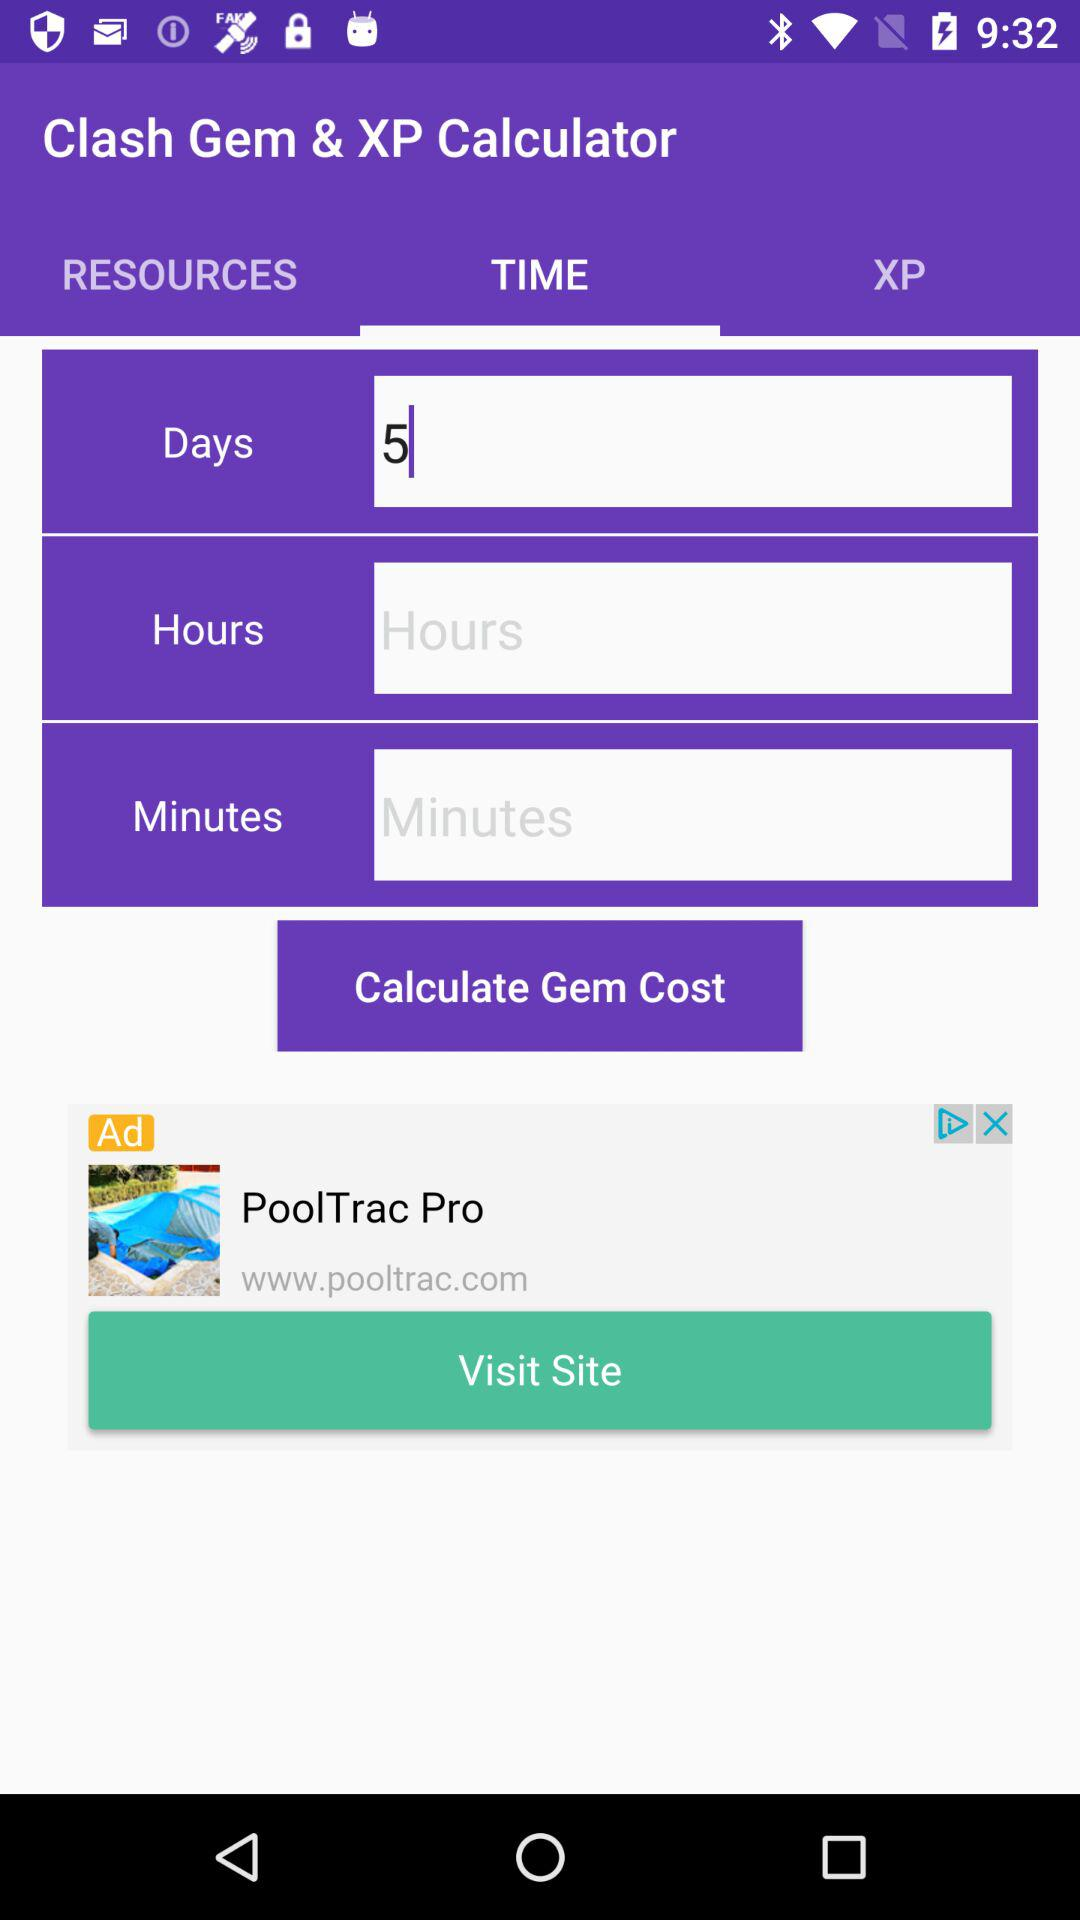What is the entered number of days? The entered number of days is 5. 